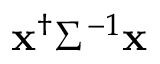Convert formula to latex. <formula><loc_0><loc_0><loc_500><loc_500>{ x } ^ { \dagger } \Sigma ^ { - 1 } { x }</formula> 